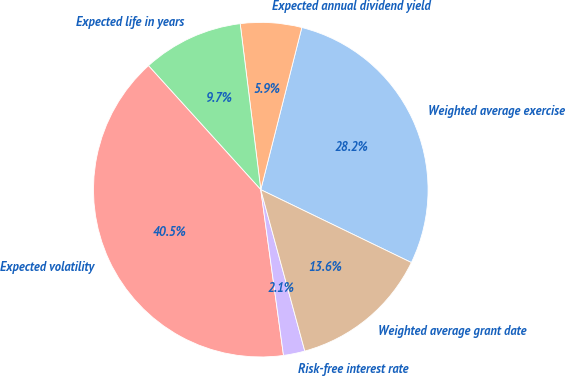Convert chart to OTSL. <chart><loc_0><loc_0><loc_500><loc_500><pie_chart><fcel>Weighted average exercise<fcel>Expected annual dividend yield<fcel>Expected life in years<fcel>Expected volatility<fcel>Risk-free interest rate<fcel>Weighted average grant date<nl><fcel>28.23%<fcel>5.91%<fcel>9.75%<fcel>40.46%<fcel>2.07%<fcel>13.59%<nl></chart> 